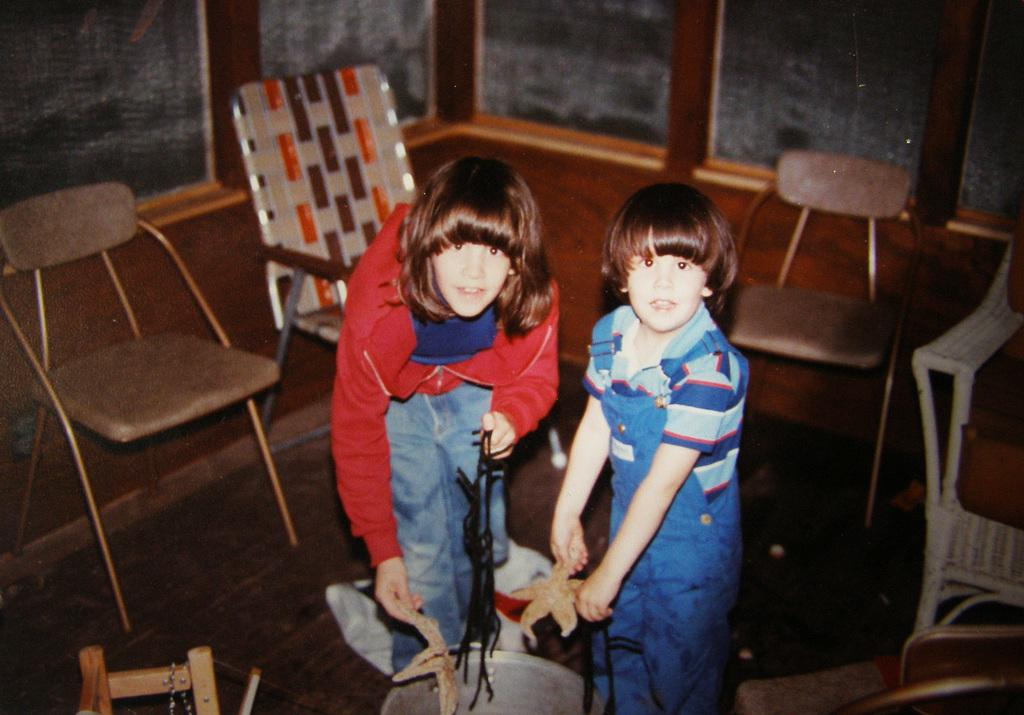How many girls are in the image? There are two girls in the image. What are the girls holding in their hands? The girls are holding cloth in their hands. What can be seen in the background of the image? There are chairs, a wall, and a bucket in the background of the image. What type of station do the girls belong to in the image? There is no reference to a station or any organization in the image; it simply features two girls holding cloth. 